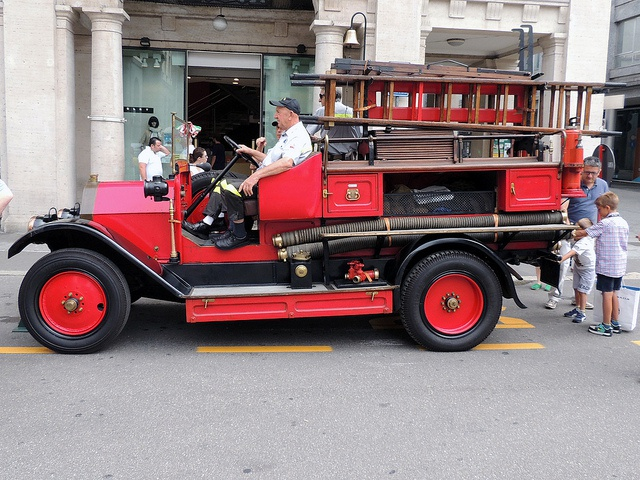Describe the objects in this image and their specific colors. I can see truck in darkgray, black, red, and gray tones, people in darkgray, black, white, gray, and lightpink tones, people in darkgray, lavender, and brown tones, people in darkgray, lavender, and gray tones, and people in darkgray, gray, and brown tones in this image. 